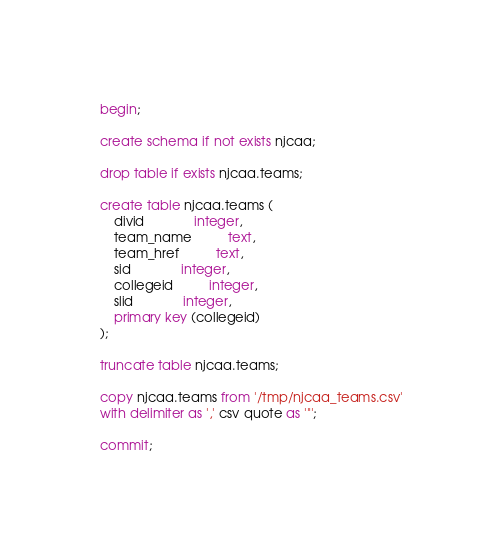Convert code to text. <code><loc_0><loc_0><loc_500><loc_500><_SQL_>begin;

create schema if not exists njcaa;

drop table if exists njcaa.teams;

create table njcaa.teams (
	divid		      integer,
	team_name	      text,
	team_href	      text,
	sid		      integer,
	collegeid	      integer,
	slid		      integer,
	primary key (collegeid)
);

truncate table njcaa.teams;

copy njcaa.teams from '/tmp/njcaa_teams.csv'
with delimiter as ',' csv quote as '"';

commit;
</code> 